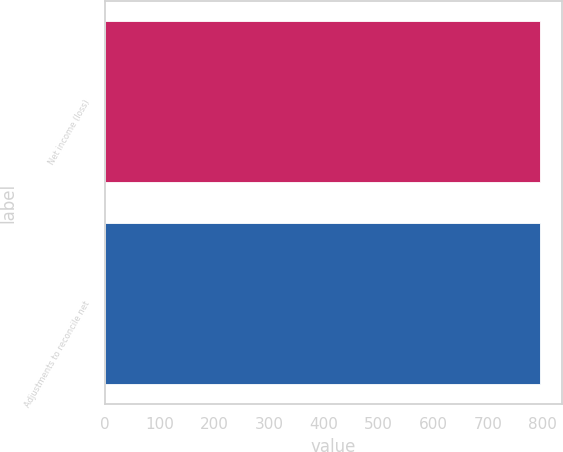Convert chart. <chart><loc_0><loc_0><loc_500><loc_500><bar_chart><fcel>Net income (loss)<fcel>Adjustments to reconcile net<nl><fcel>795<fcel>795.1<nl></chart> 